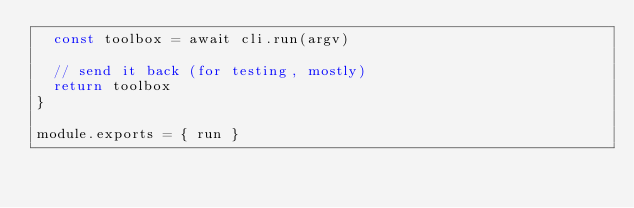Convert code to text. <code><loc_0><loc_0><loc_500><loc_500><_JavaScript_>  const toolbox = await cli.run(argv)

  // send it back (for testing, mostly)
  return toolbox
}

module.exports = { run }
</code> 